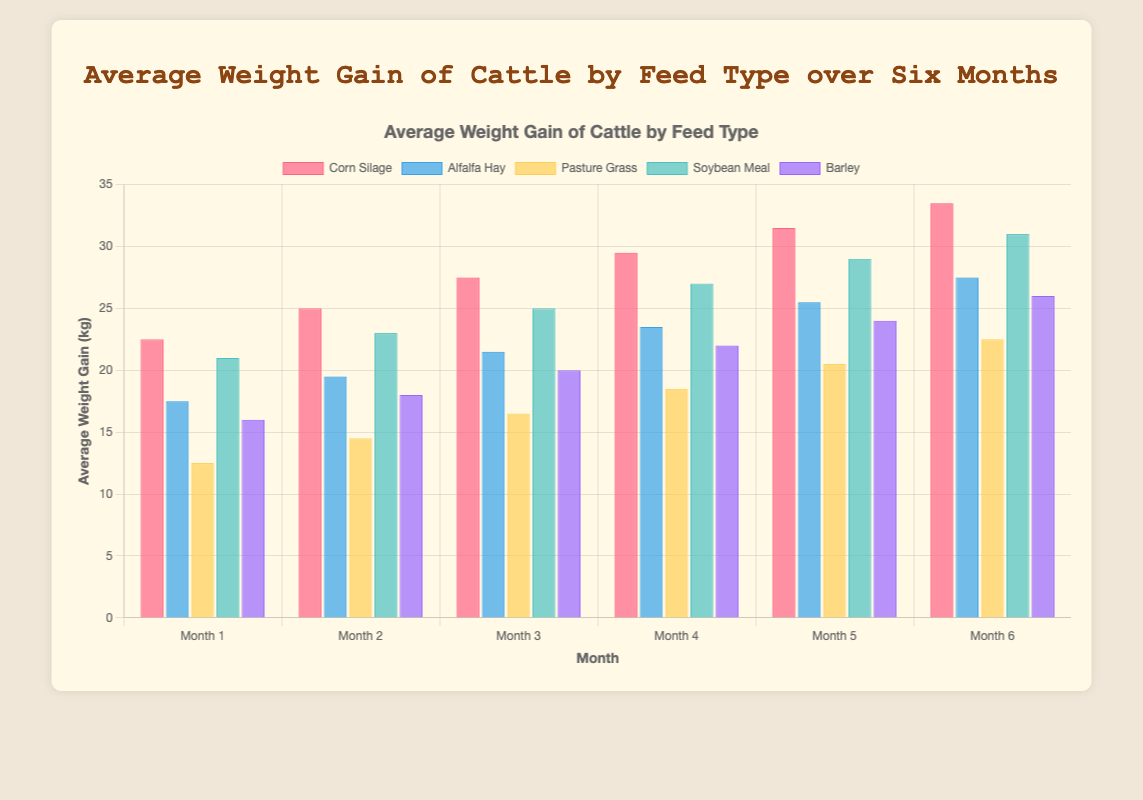What is the average weight gain of cattle fed with Corn Silage in Month 3? The bar corresponding to "Corn Silage" for "Month 3" shows an average weight gain. Simply read the value from the bar. The average weight gain is 27.5 kg.
Answer: 27.5 kg Compare the average weight gains in Month 6 for Soybean Meal and Alfalfa Hay. Which feed type shows higher gains? Look at the bars for "Soybean Meal" and "Alfalfa Hay" in "Month 6". The bar for "Soybean Meal" shows an average weight gain of 31 kg, while the bar for "Alfalfa Hay" shows an average weight gain of 27.5 kg. Hence, Soybean Meal shows higher gains.
Answer: Soybean Meal Between Pasture Grass and Barley, which feed type had a more consistent increase in average weight gain over the six months? To determine consistency, observe the increasing trend in the bars for both "Pasture Grass" and "Barley". The difference between each month's weight gain should be relatively uniform. "Pasture Grass" shows a consistent increase of ~2 kg each month, while "Barley" shows an increase of ~2 kg each month as well but with a slight variation. Both show similar consistencies but if you consider strict uniformity, Pasture Grass is a bit more consistent.
Answer: Pasture Grass What is the total average weight gain for all feed types in Month 5? Add up the average weight gains for "Corn Silage", "Alfalfa Hay", "Pasture Grass", "Soybean Meal", and "Barley" in "Month 5". The values are: 31.5, 25.5, 20.5, 29, and 24 kg. Sum them: 31.5 + 25.5 + 20.5 + 29 + 24 = 130.5 kg.
Answer: 130.5 kg Which feed type has the lowest average weight gain in Month 1, and what is the value? Look at the bars for all feed types in "Month 1". Identify the smallest bar, which represents the lowest average weight gain. The bar for "Pasture Grass" is the smallest with an average weight gain of 12.5 kg.
Answer: Pasture Grass, 12.5 kg How does the average weight gain in Month 4 compare between Corn Silage and Soybean Meal? Check the bars for "Corn Silage" and "Soybean Meal" in "Month 4". The average weight gain for Corn Silage is 29.5 kg, and for Soybean Meal, it is 27 kg. Corn Silage has a higher average weight gain by 2.5 kg.
Answer: Corn Silage, 2.5 kg more What is the average monthly weight gain increase for Barley from Month 1 to Month 6? Calculate the average weight gain each month for "Barley" from "Month 1" to "Month 6", then find the monthly increase: 
- Increment: (18-16), (20-18), (22-20), (24-22), (26-24)
- Total increment over the months = 2+2+2+2+2 = 10 kg
- Divide by 5 to find the monthly increase: 10 kg / 5 = 2 kg per month
Answer: 2 kg per month 